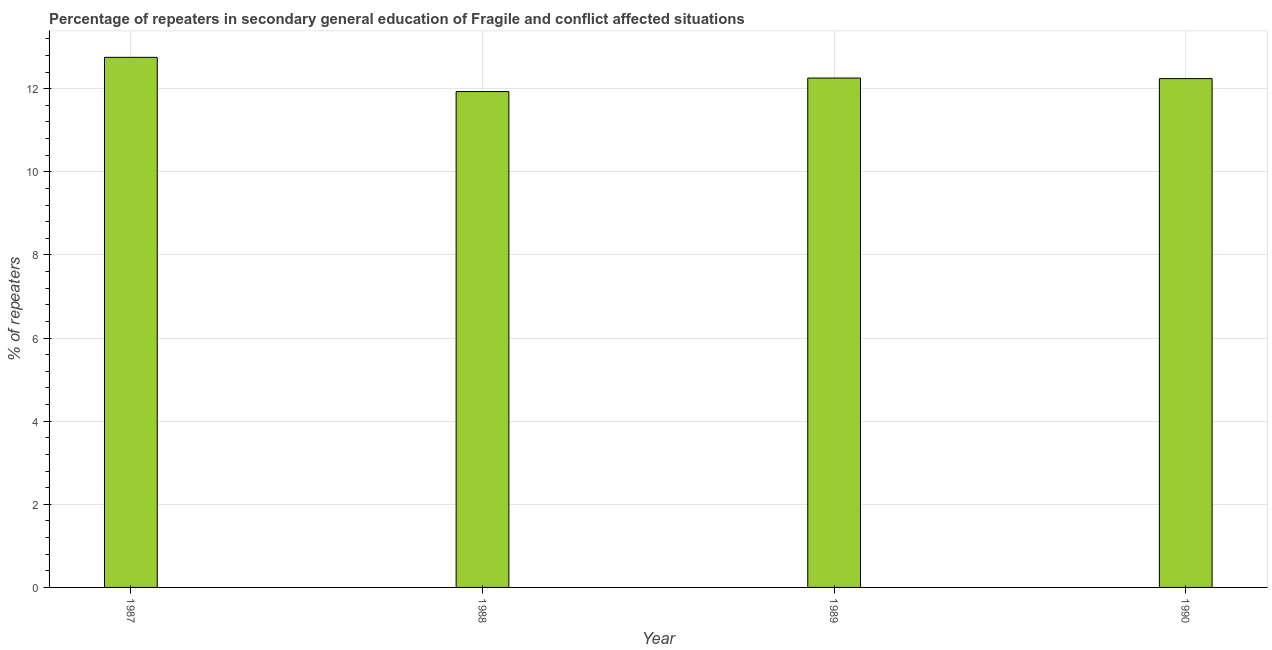What is the title of the graph?
Your answer should be very brief. Percentage of repeaters in secondary general education of Fragile and conflict affected situations. What is the label or title of the Y-axis?
Give a very brief answer. % of repeaters. What is the percentage of repeaters in 1989?
Offer a very short reply. 12.26. Across all years, what is the maximum percentage of repeaters?
Your response must be concise. 12.75. Across all years, what is the minimum percentage of repeaters?
Provide a succinct answer. 11.93. In which year was the percentage of repeaters maximum?
Your answer should be compact. 1987. In which year was the percentage of repeaters minimum?
Keep it short and to the point. 1988. What is the sum of the percentage of repeaters?
Your response must be concise. 49.18. What is the difference between the percentage of repeaters in 1987 and 1990?
Offer a very short reply. 0.51. What is the average percentage of repeaters per year?
Your answer should be compact. 12.3. What is the median percentage of repeaters?
Offer a very short reply. 12.25. Is the difference between the percentage of repeaters in 1988 and 1990 greater than the difference between any two years?
Give a very brief answer. No. What is the difference between the highest and the second highest percentage of repeaters?
Your answer should be very brief. 0.5. What is the difference between the highest and the lowest percentage of repeaters?
Offer a terse response. 0.82. How many bars are there?
Offer a terse response. 4. Are all the bars in the graph horizontal?
Your answer should be very brief. No. How many years are there in the graph?
Your answer should be compact. 4. What is the difference between two consecutive major ticks on the Y-axis?
Provide a succinct answer. 2. What is the % of repeaters of 1987?
Provide a succinct answer. 12.75. What is the % of repeaters in 1988?
Provide a short and direct response. 11.93. What is the % of repeaters in 1989?
Provide a succinct answer. 12.26. What is the % of repeaters of 1990?
Provide a short and direct response. 12.24. What is the difference between the % of repeaters in 1987 and 1988?
Your response must be concise. 0.82. What is the difference between the % of repeaters in 1987 and 1989?
Your response must be concise. 0.5. What is the difference between the % of repeaters in 1987 and 1990?
Your answer should be compact. 0.51. What is the difference between the % of repeaters in 1988 and 1989?
Offer a terse response. -0.33. What is the difference between the % of repeaters in 1988 and 1990?
Offer a terse response. -0.31. What is the difference between the % of repeaters in 1989 and 1990?
Provide a succinct answer. 0.01. What is the ratio of the % of repeaters in 1987 to that in 1988?
Give a very brief answer. 1.07. What is the ratio of the % of repeaters in 1987 to that in 1989?
Keep it short and to the point. 1.04. What is the ratio of the % of repeaters in 1987 to that in 1990?
Provide a succinct answer. 1.04. What is the ratio of the % of repeaters in 1988 to that in 1990?
Make the answer very short. 0.97. What is the ratio of the % of repeaters in 1989 to that in 1990?
Offer a terse response. 1. 